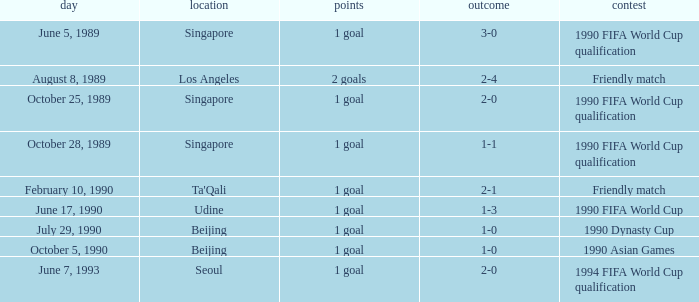What is the venue of the 1990 Asian games? Beijing. 